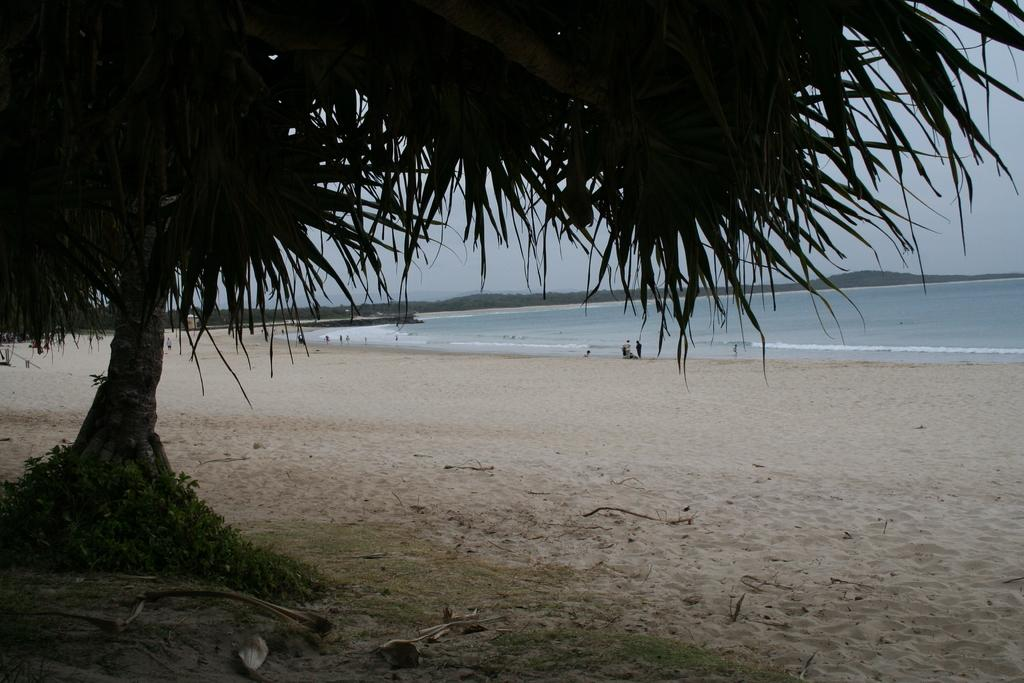What is located in the foreground of the image? There is a tree in the foreground of the image. What type of terrain is visible at the bottom of the image? There is sand at the bottom of the image. What can be seen in the background of the image? There is a beach, persons, and trees in the background of the image. What is visible at the top of the image? The sky is visible at the top of the image. What type of books can be found in the library depicted in the image? There is no library present in the image; it features a tree in the foreground, sand at the bottom, a beach, persons, and trees in the background, and a visible sky. What belief system is being practiced by the persons in the image? There is no indication of any belief system being practiced by the persons in the image; they are simply present in the background of the image. 